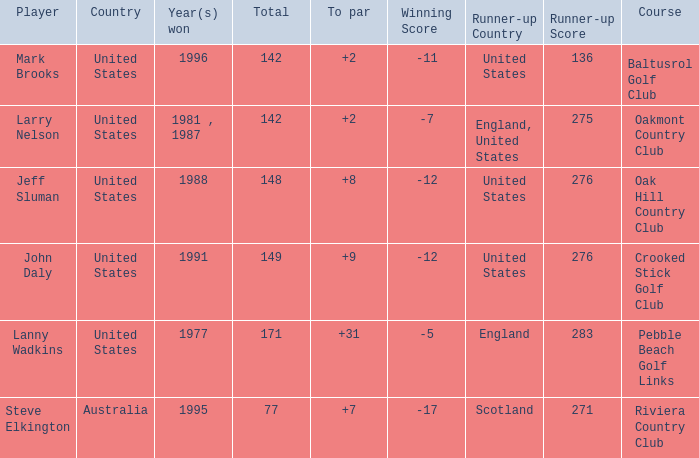I'm looking to parse the entire table for insights. Could you assist me with that? {'header': ['Player', 'Country', 'Year(s) won', 'Total', 'To par', 'Winning Score', 'Runner-up Country', 'Runner-up Score', 'Course'], 'rows': [['Mark Brooks', 'United States', '1996', '142', '+2', '-11', 'United States', '136', 'Baltusrol Golf Club'], ['Larry Nelson', 'United States', '1981 , 1987', '142', '+2', '-7', 'England, United States', '275', 'Oakmont Country Club'], ['Jeff Sluman', 'United States', '1988', '148', '+8', '-12', 'United States', '276', 'Oak Hill Country Club'], ['John Daly', 'United States', '1991', '149', '+9', '-12', 'United States', '276', 'Crooked Stick Golf Club'], ['Lanny Wadkins', 'United States', '1977', '171', '+31', '-5', 'England', '283', 'Pebble Beach Golf Links'], ['Steve Elkington', 'Australia', '1995', '77', '+7', '-17', 'Scotland', '271', 'Riviera Country Club']]} Name the To par that has a Year(s) won of 1988 and a Total smaller than 148? None. 